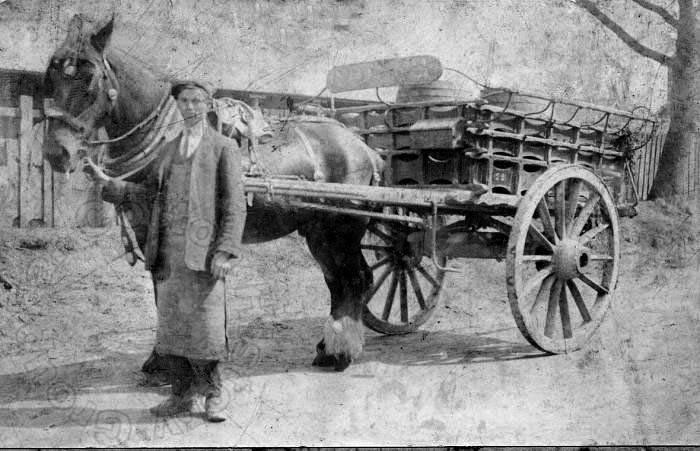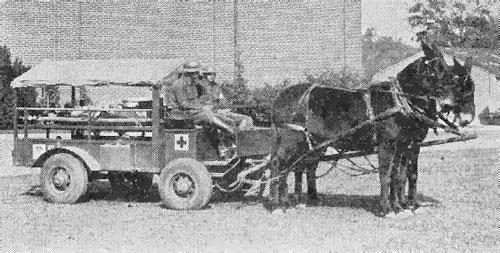The first image is the image on the left, the second image is the image on the right. Analyze the images presented: Is the assertion "The left image shows a two-wheeled wagon with no passengers." valid? Answer yes or no. Yes. The first image is the image on the left, the second image is the image on the right. Given the left and right images, does the statement "Two horses are pulling a single cart in the image on the right." hold true? Answer yes or no. Yes. 